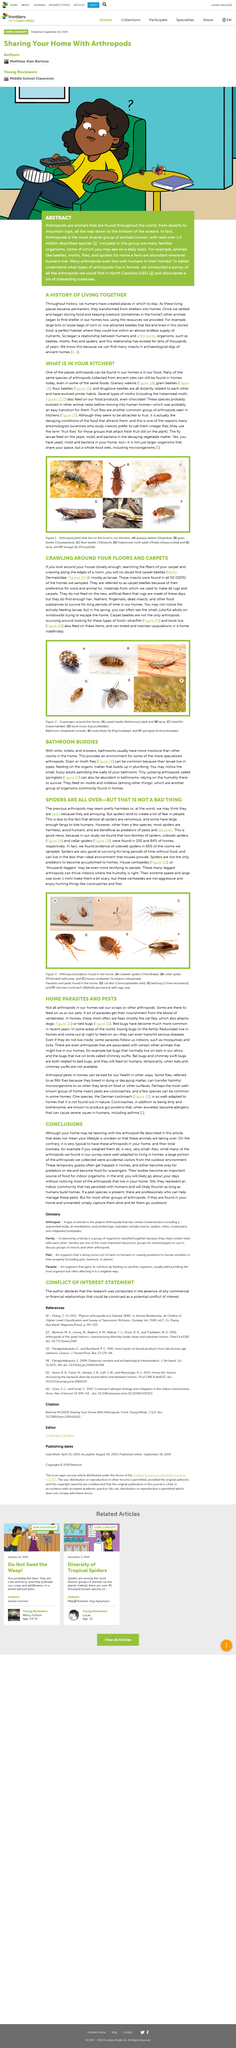Outline some significant characteristics in this image. Spiders are venomous and have large enough fangs to bite humans, which instills fear in many people. The insect found in all 50 of the houses sampled was a type of carpet beetle. House centipedes are commonly known as "thousand-leggers. Carpet beetles belong to the family Dermestidae, known for their destructive habits and ability to infest a wide range of materials including wool, silk, and feathers. The term used to refer to a group of insects that prey on fresh fruit that is still attached to the plant is "fruit flies. 